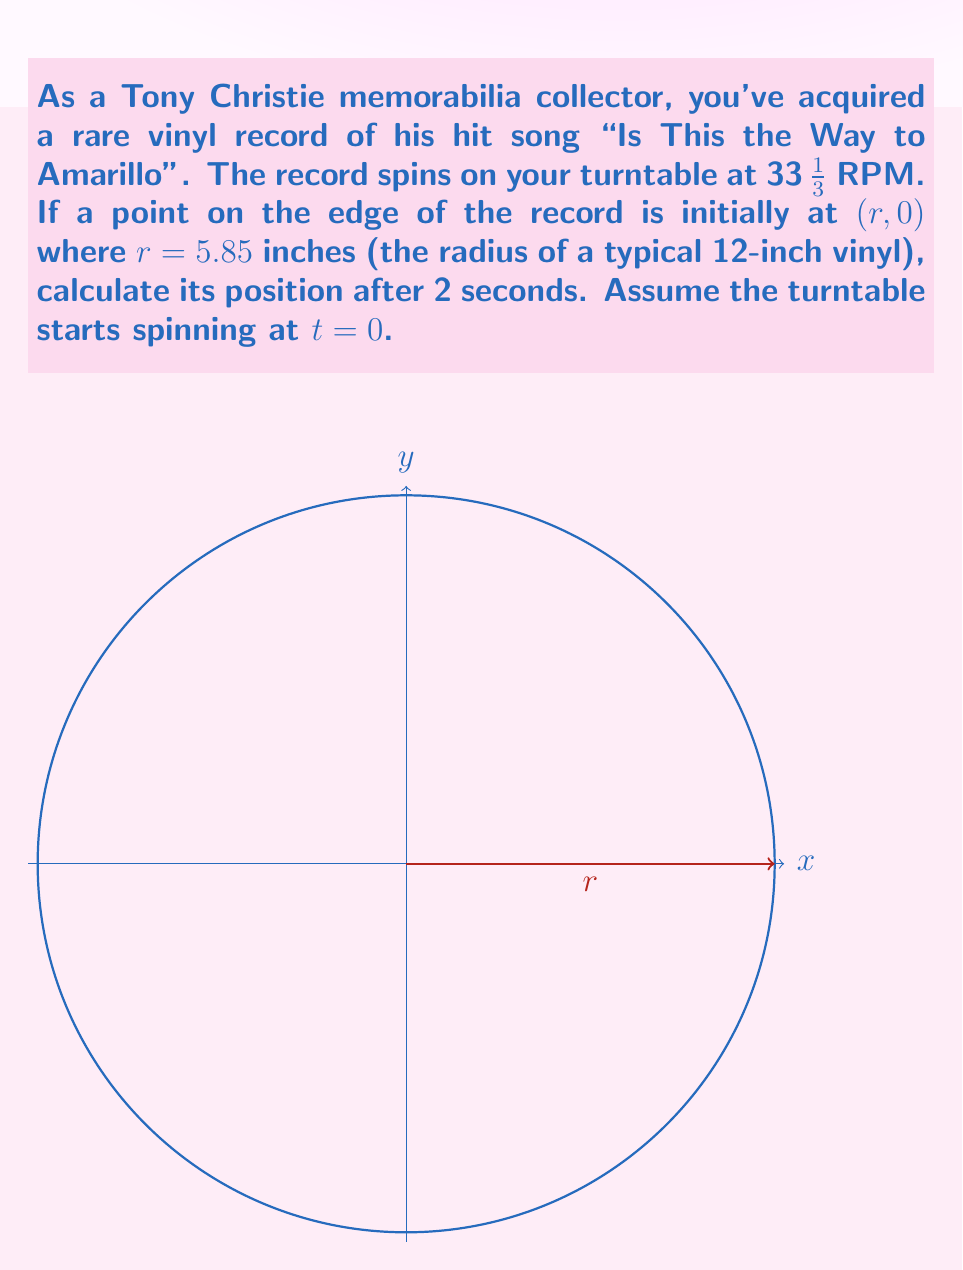What is the answer to this math problem? Let's approach this step-by-step:

1) First, we need to convert the turntable's speed from RPM to radians per second:
   $$\omega = 33\frac{1}{3} \cdot \frac{2\pi}{60} = \frac{10\pi}{9} \approx 3.49 \text{ rad/s}$$

2) The parametric equations for a point moving in a circle are:
   $$x = r\cos(\omega t)$$
   $$y = r\sin(\omega t)$$
   where $r$ is the radius, $\omega$ is the angular velocity, and $t$ is time.

3) We're given:
   $r = 5.85$ inches
   $t = 2$ seconds
   $\omega = \frac{10\pi}{9}$ rad/s

4) Substituting these values:
   $$x = 5.85 \cos(\frac{10\pi}{9} \cdot 2)$$
   $$y = 5.85 \sin(\frac{10\pi}{9} \cdot 2)$$

5) Simplifying:
   $$x = 5.85 \cos(\frac{20\pi}{9}) \approx -4.06$$
   $$y = 5.85 \sin(\frac{20\pi}{9}) \approx -4.21$$

6) Therefore, after 2 seconds, the point's position is approximately $(-4.06, -4.21)$ inches.
Answer: $(-4.06, -4.21)$ inches 